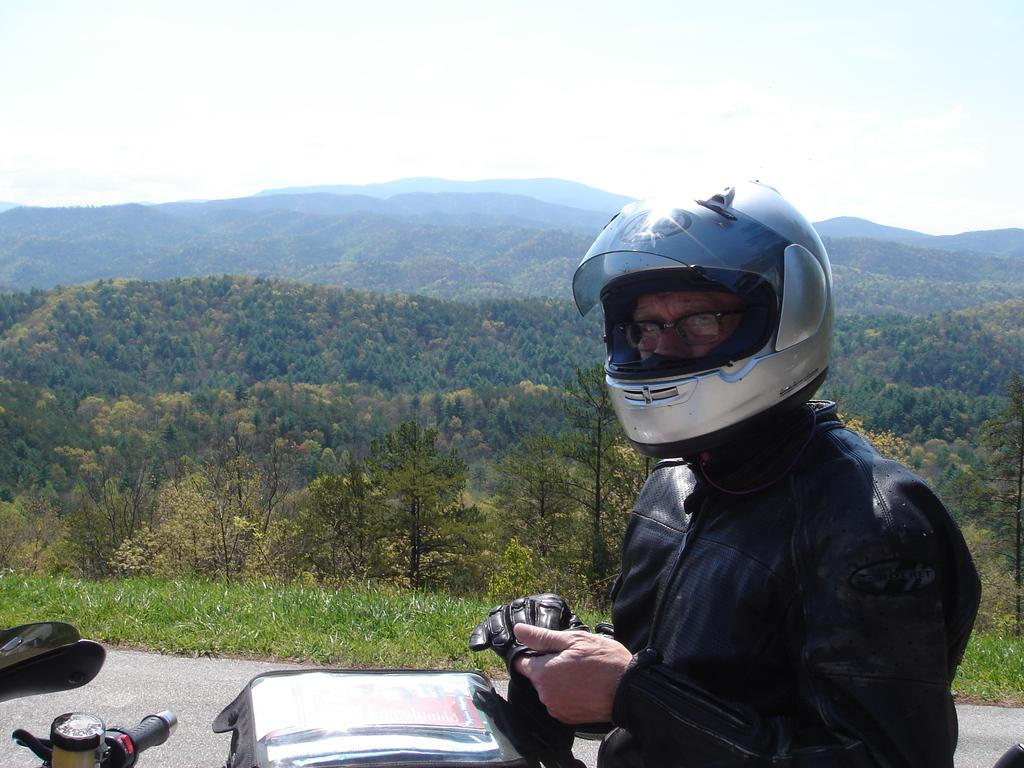Who or what is the main subject of the image? There is a person in the image. What is the person doing or riding in the image? The person is on a motorcycle. What safety gear is the person wearing in the image? The person is wearing a helmet. What type of natural scenery can be seen in the background of the image? There are trees, mountains, and the sky visible in the background of the image. What type of canvas is the person painting in the image? There is no canvas or painting activity present in the image; the person is riding a motorcycle. What type of berry can be seen growing on the trees in the background of the image? There is no mention of berries or any specific type of vegetation on the trees in the image. 